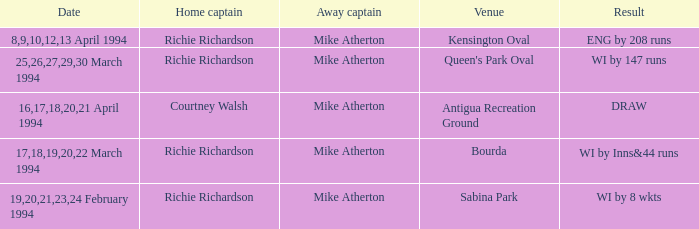What is the Venue which has a Wi by 8 wkts? Sabina Park. 